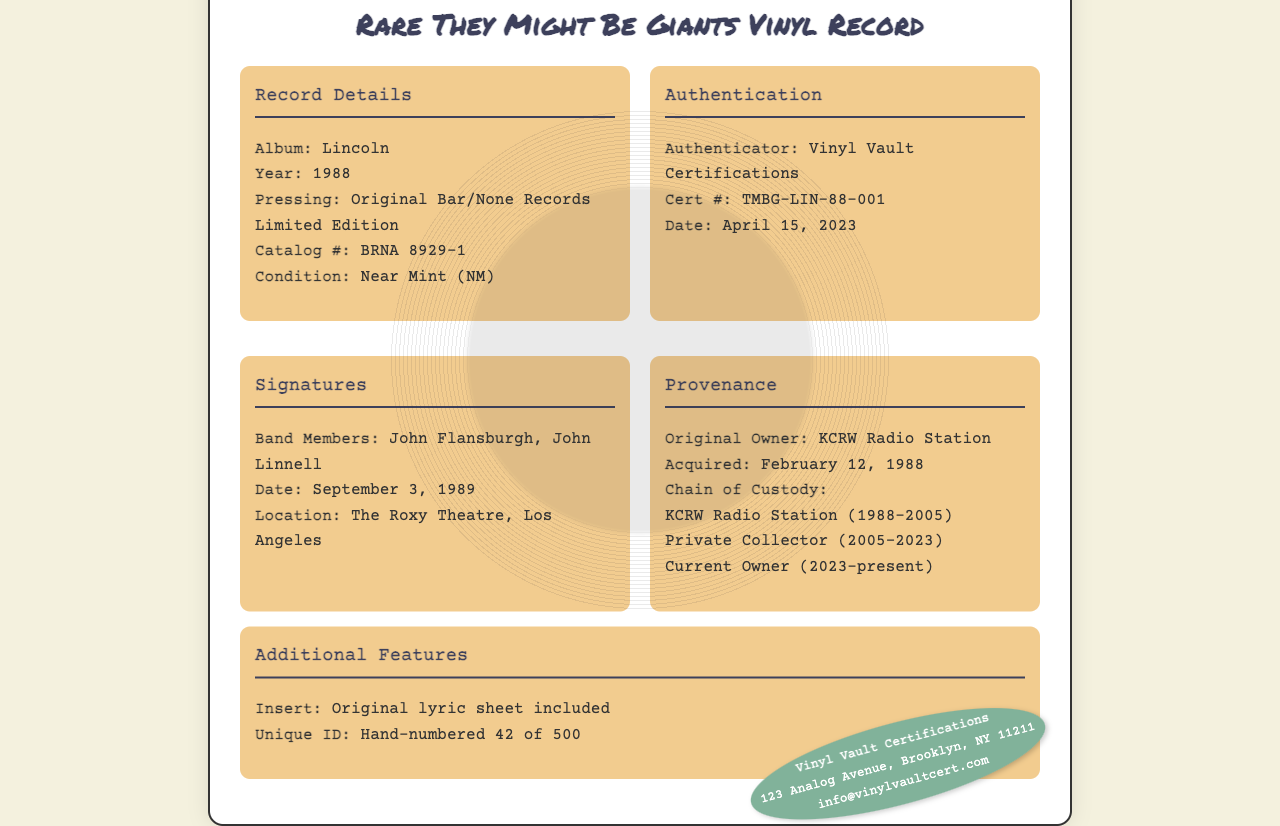What is the album title? The album title is mentioned in the Record Details section of the document.
Answer: Lincoln Who authenticated the record? The authenticator's name is provided in the Authentication section of the document.
Answer: Vinyl Vault Certifications What is the catalog number? The catalog number can be found in the Record Details section of the document.
Answer: BRNA 8929-1 When was the certificate issued? The issuance date is noted in the Authentication section of the document.
Answer: April 15, 2023 How many copies were made? The unique ID information states the total number of copies in the Additional Features section.
Answer: 500 Who were the band members who signed? The names of the signing band members can be found in the Signatures section.
Answer: John Flansburgh, John Linnell What is the condition of the vinyl? The condition of the vinyl record is described in the Record Details section.
Answer: Near Mint (NM) Where was the record signed? The location of the signing is mentioned in the Signatures section of the document.
Answer: The Roxy Theatre, Los Angeles What is the unique hand-numbered ID of this record? The unique ID is listed in the Additional Features section of the document.
Answer: 42 of 500 